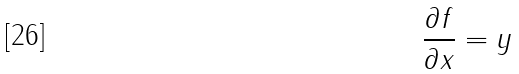Convert formula to latex. <formula><loc_0><loc_0><loc_500><loc_500>\frac { \partial f } { \partial x } = y</formula> 